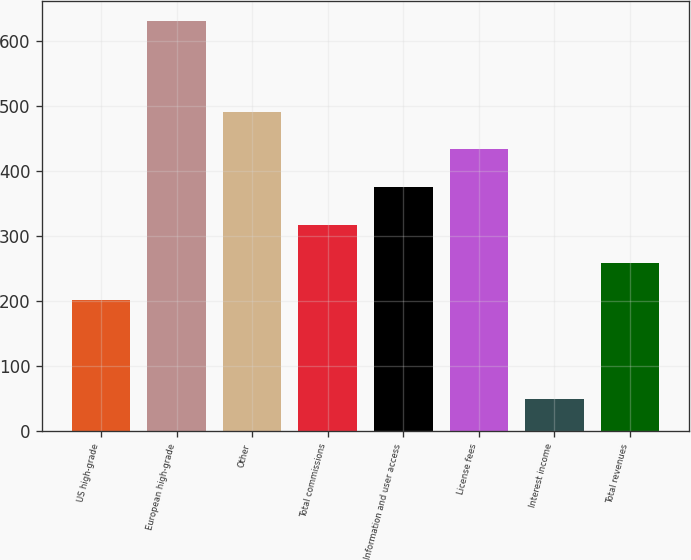Convert chart. <chart><loc_0><loc_0><loc_500><loc_500><bar_chart><fcel>US high-grade<fcel>European high-grade<fcel>Other<fcel>Total commissions<fcel>Information and user access<fcel>License fees<fcel>Interest income<fcel>Total revenues<nl><fcel>201.1<fcel>630.8<fcel>491.5<fcel>317.26<fcel>375.34<fcel>433.42<fcel>50<fcel>259.18<nl></chart> 